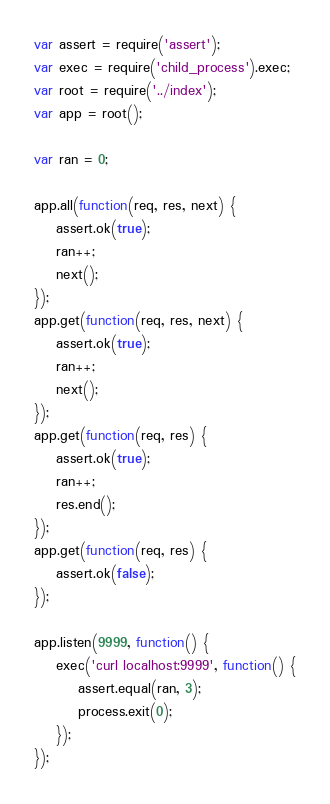Convert code to text. <code><loc_0><loc_0><loc_500><loc_500><_JavaScript_>var assert = require('assert');
var exec = require('child_process').exec;
var root = require('../index');
var app = root();

var ran = 0;

app.all(function(req, res, next) {
	assert.ok(true);
	ran++;
	next();
});
app.get(function(req, res, next) {
	assert.ok(true);
	ran++;
	next();
});
app.get(function(req, res) {
	assert.ok(true);
	ran++;
	res.end();
});
app.get(function(req, res) {
	assert.ok(false);
});

app.listen(9999, function() {
	exec('curl localhost:9999', function() {
		assert.equal(ran, 3);
		process.exit(0);
	});
});</code> 